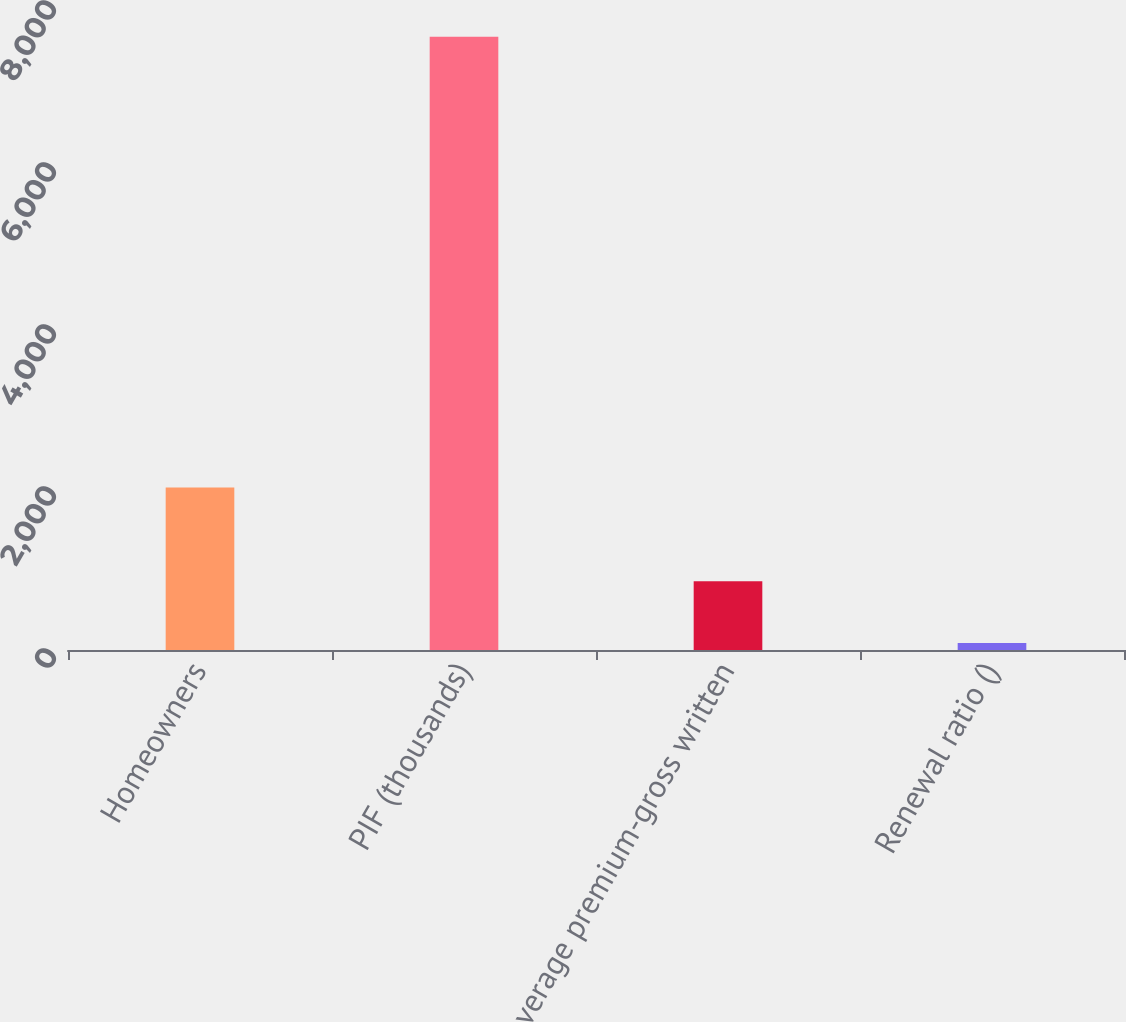Convert chart to OTSL. <chart><loc_0><loc_0><loc_500><loc_500><bar_chart><fcel>Homeowners<fcel>PIF (thousands)<fcel>Average premium-gross written<fcel>Renewal ratio ()<nl><fcel>2007<fcel>7570<fcel>850<fcel>86.5<nl></chart> 